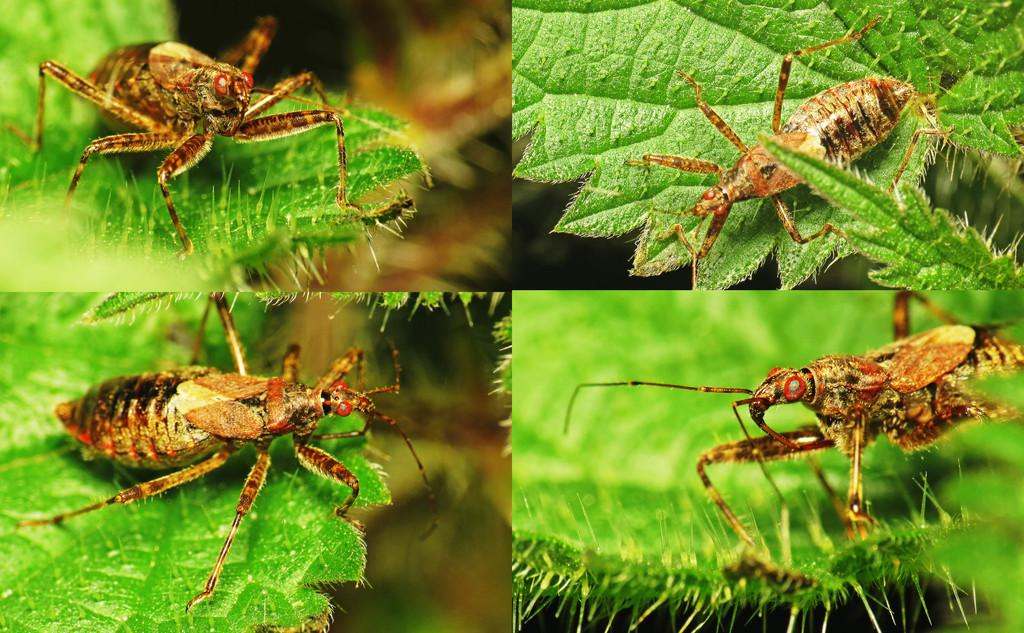What is the main subject of the image? The image contains a collage. What is included in the collage? The collage includes a picture. What is shown in the picture? The picture depicts an insect. Where is the insect located in the image? The insect is on a leaf. Can you tell me how many basketballs are visible in the image? There are no basketballs present in the image. What type of jewel is the insect holding in the image? There is no jewel present in the image, and the insect is not holding anything. 